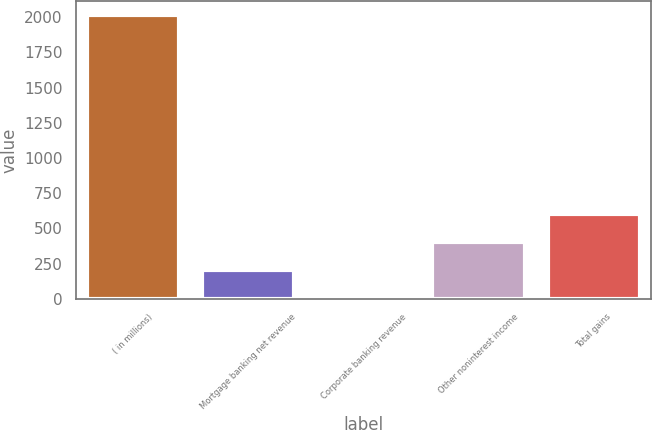<chart> <loc_0><loc_0><loc_500><loc_500><bar_chart><fcel>( in millions)<fcel>Mortgage banking net revenue<fcel>Corporate banking revenue<fcel>Other noninterest income<fcel>Total gains<nl><fcel>2013<fcel>202.2<fcel>1<fcel>403.4<fcel>604.6<nl></chart> 